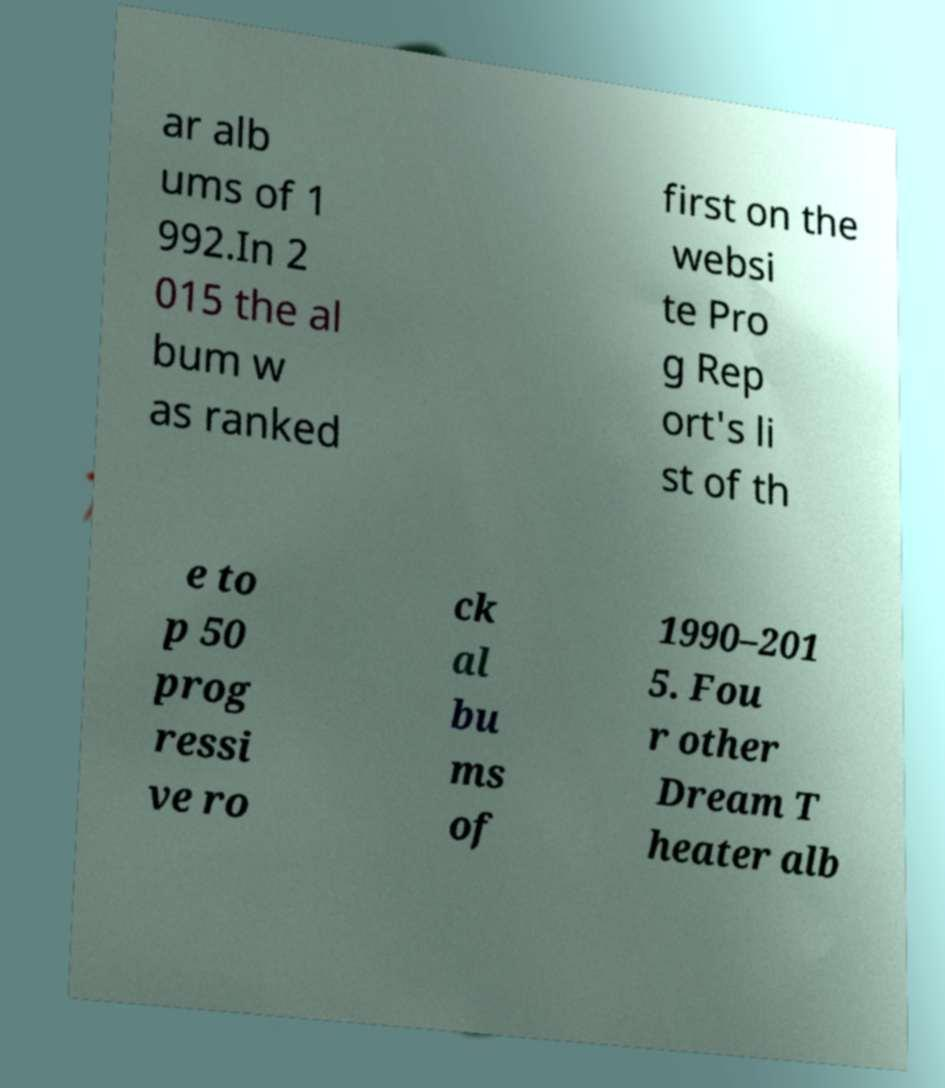Could you assist in decoding the text presented in this image and type it out clearly? ar alb ums of 1 992.In 2 015 the al bum w as ranked first on the websi te Pro g Rep ort's li st of th e to p 50 prog ressi ve ro ck al bu ms of 1990–201 5. Fou r other Dream T heater alb 